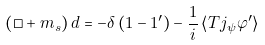<formula> <loc_0><loc_0><loc_500><loc_500>\left ( \Box + m _ { s } \right ) d = - \delta \left ( 1 - 1 ^ { \prime } \right ) - \frac { 1 } { i } \left < T j _ { \psi } \varphi ^ { \prime } \right ></formula> 